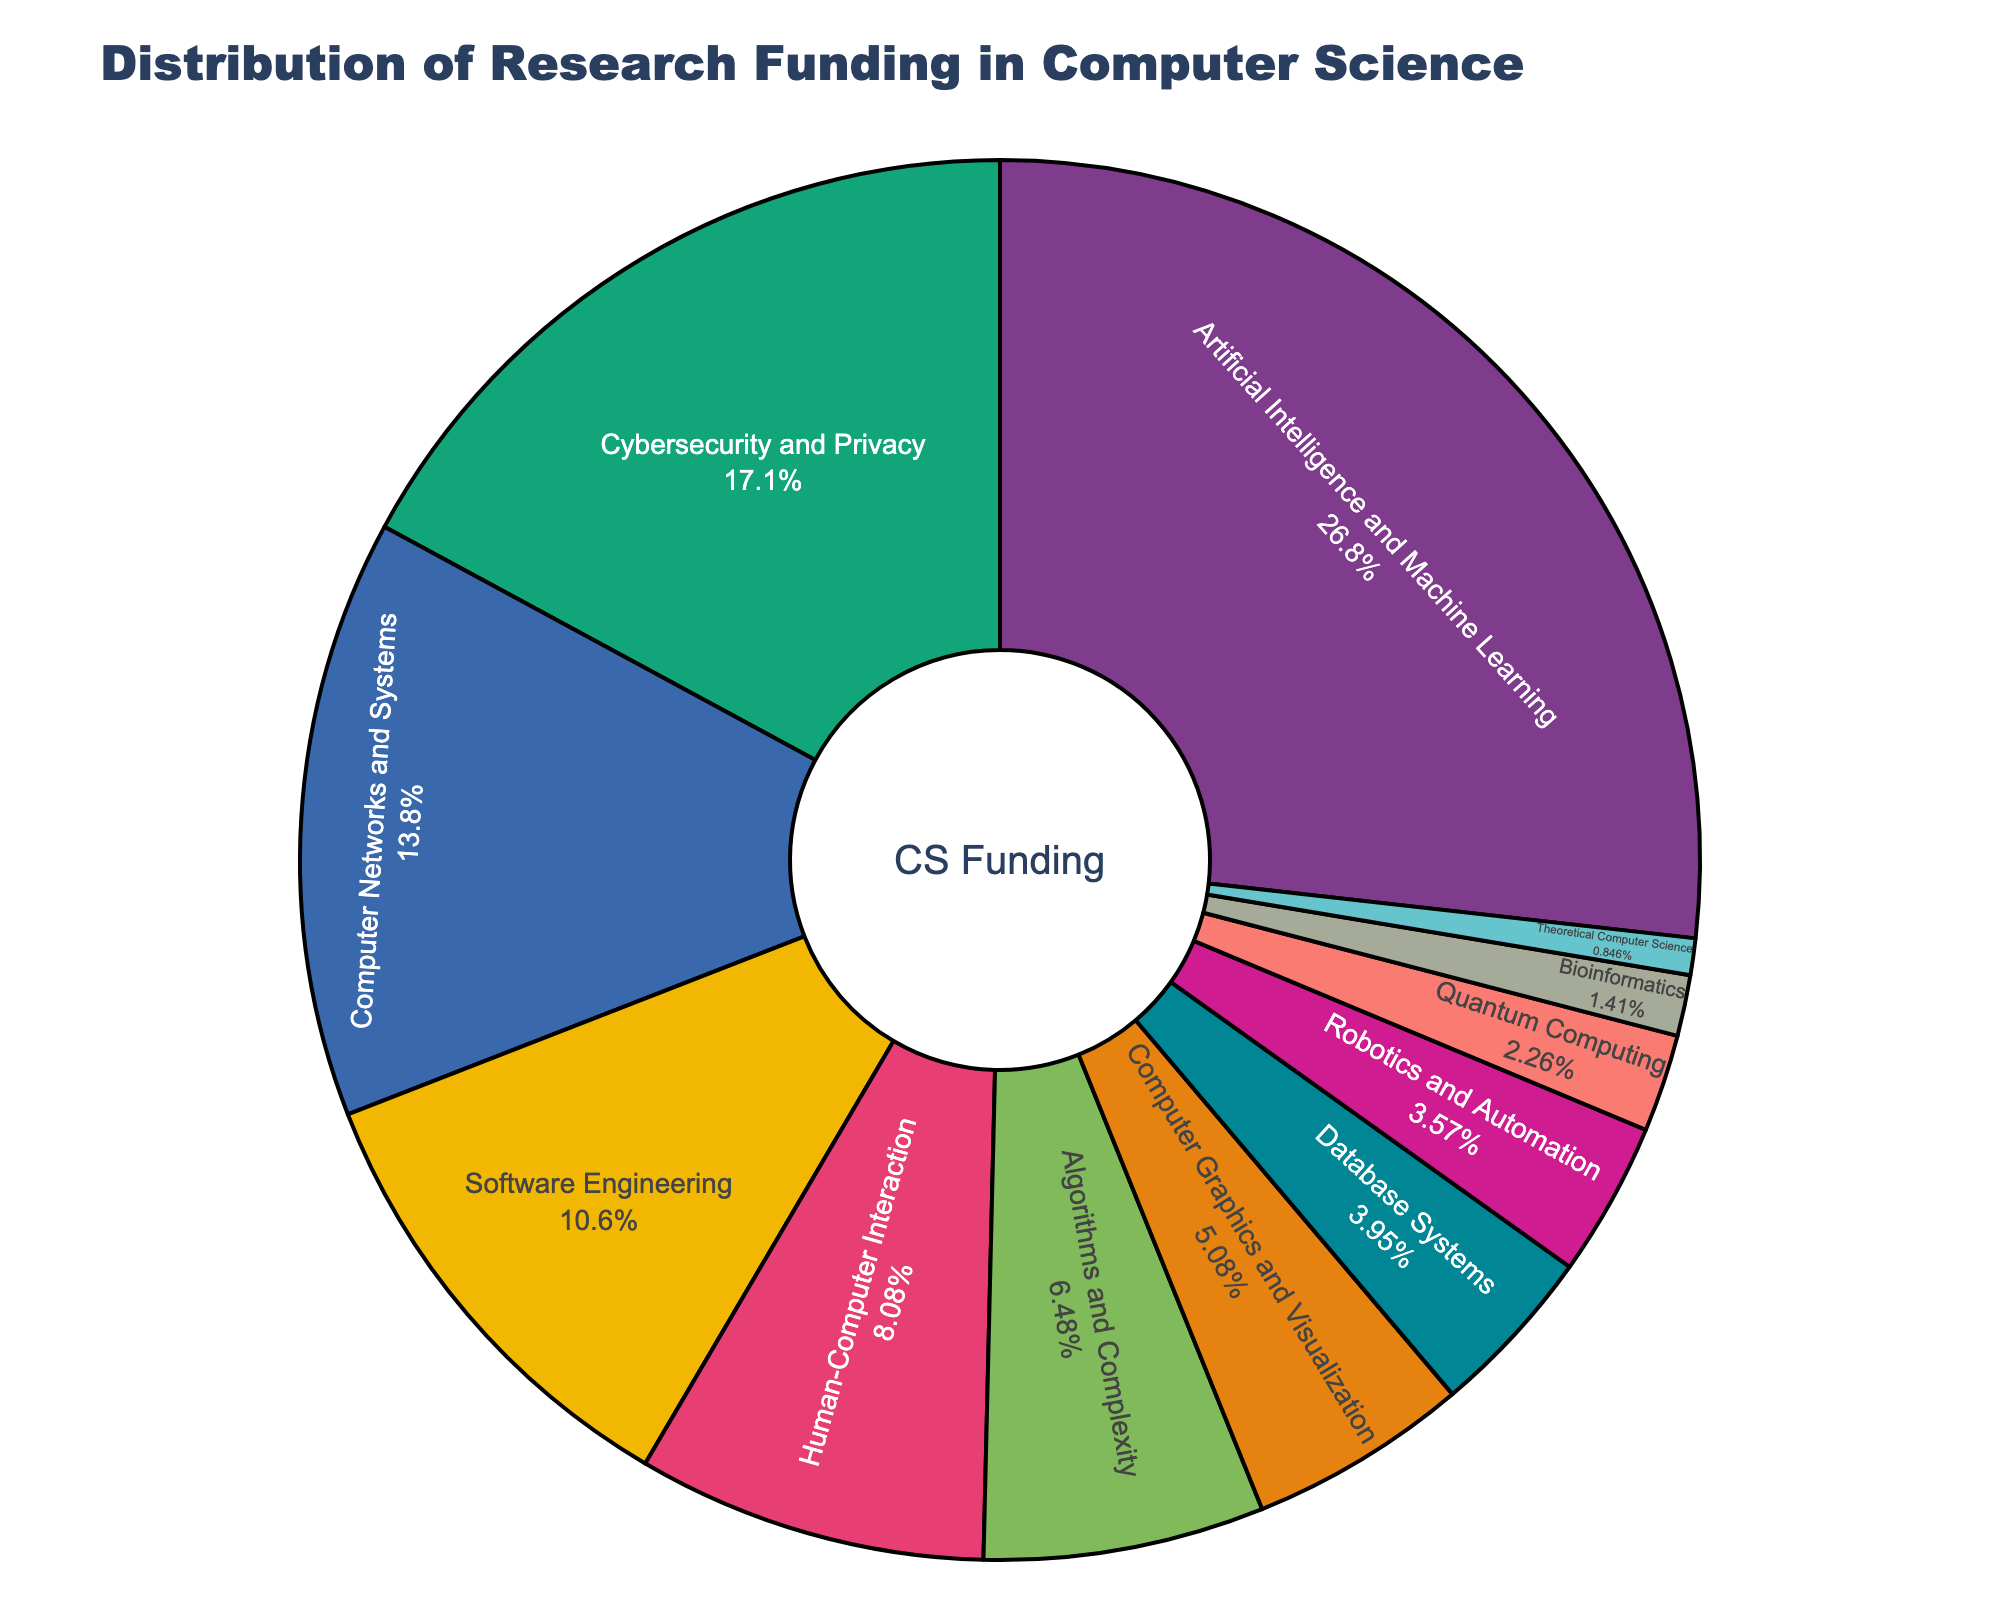What is the sub-discipline receiving the highest percentage of research funding? The sub-discipline "Artificial Intelligence and Machine Learning" is at the top with the largest segment in the pie chart.
Answer: Artificial Intelligence and Machine Learning What is the combined percentage of research funding for Cybersecurity and Privacy, and Algorithms and Complexity? Add the percentages of Cybersecurity and Privacy (18.2%) and Algorithms and Complexity (6.9%): 18.2 + 6.9 = 25.1%.
Answer: 25.1% Which sub-discipline has a higher funding percentage, Software Engineering or Computer Networks and Systems? Compare the two percentages: Software Engineering has 11.3% while Computer Networks and Systems has 14.7%. Computer Networks and Systems is higher.
Answer: Computer Networks and Systems What is the total percentage of research funding allocated to sub-disciplines that receive less than 5% each? Sum the percentages for sub-disciplines receiving less than 5%: Database Systems (4.2%), Robotics and Automation (3.8%), Quantum Computing (2.4%), Bioinformatics (1.5%), Theoretical Computer Science (0.9%) which totals: 4.2 + 3.8 + 2.4 + 1.5 + 0.9 = 12.8%.
Answer: 12.8% Which sub-discipline has the smallest funding percentage, and what is that percentage? The smallest segment represents Theoretical Computer Science with 0.9%.
Answer: Theoretical Computer Science, 0.9% Is the funding for Human-Computer Interaction more than double the funding for Quantum Computing? Check if 8.6% (Human-Computer Interaction) is more than double of 2.4% (Quantum Computing): Double of 2.4 is 4.8, and 8.6 is indeed more than 4.8.
Answer: Yes What is the percentage difference in funding between Artificial Intelligence and Machine Learning and Cybersecurity and Privacy? Subtract the percentage of Cybersecurity and Privacy (18.2%) from Artificial Intelligence and Machine Learning (28.5%): 28.5 - 18.2 = 10.3%.
Answer: 10.3% If you combine the funding percentages for Database Systems and Computer Graphics and Visualization, how much more or less is this combined total compared to the funding for Human-Computer Interaction? Add Database Systems (4.2%) and Computer Graphics and Visualization (5.4%) to get 9.6%. Then subtract Human-Computer Interaction's percentage (8.6%) from 9.6% to find the difference: 9.6 - 8.6 = 1%.
Answer: 1% more What is the median funding percentage of the sub-disciplines listed? Order the percentages: 0.9, 1.5, 2.4, 3.8, 4.2, 5.4, 6.9, 8.6, 11.3, 14.7, 18.2, 28.5. The median value is the average of the 6th and 7th values: (5.4 + 6.9) / 2 = 6.15.
Answer: 6.15% 